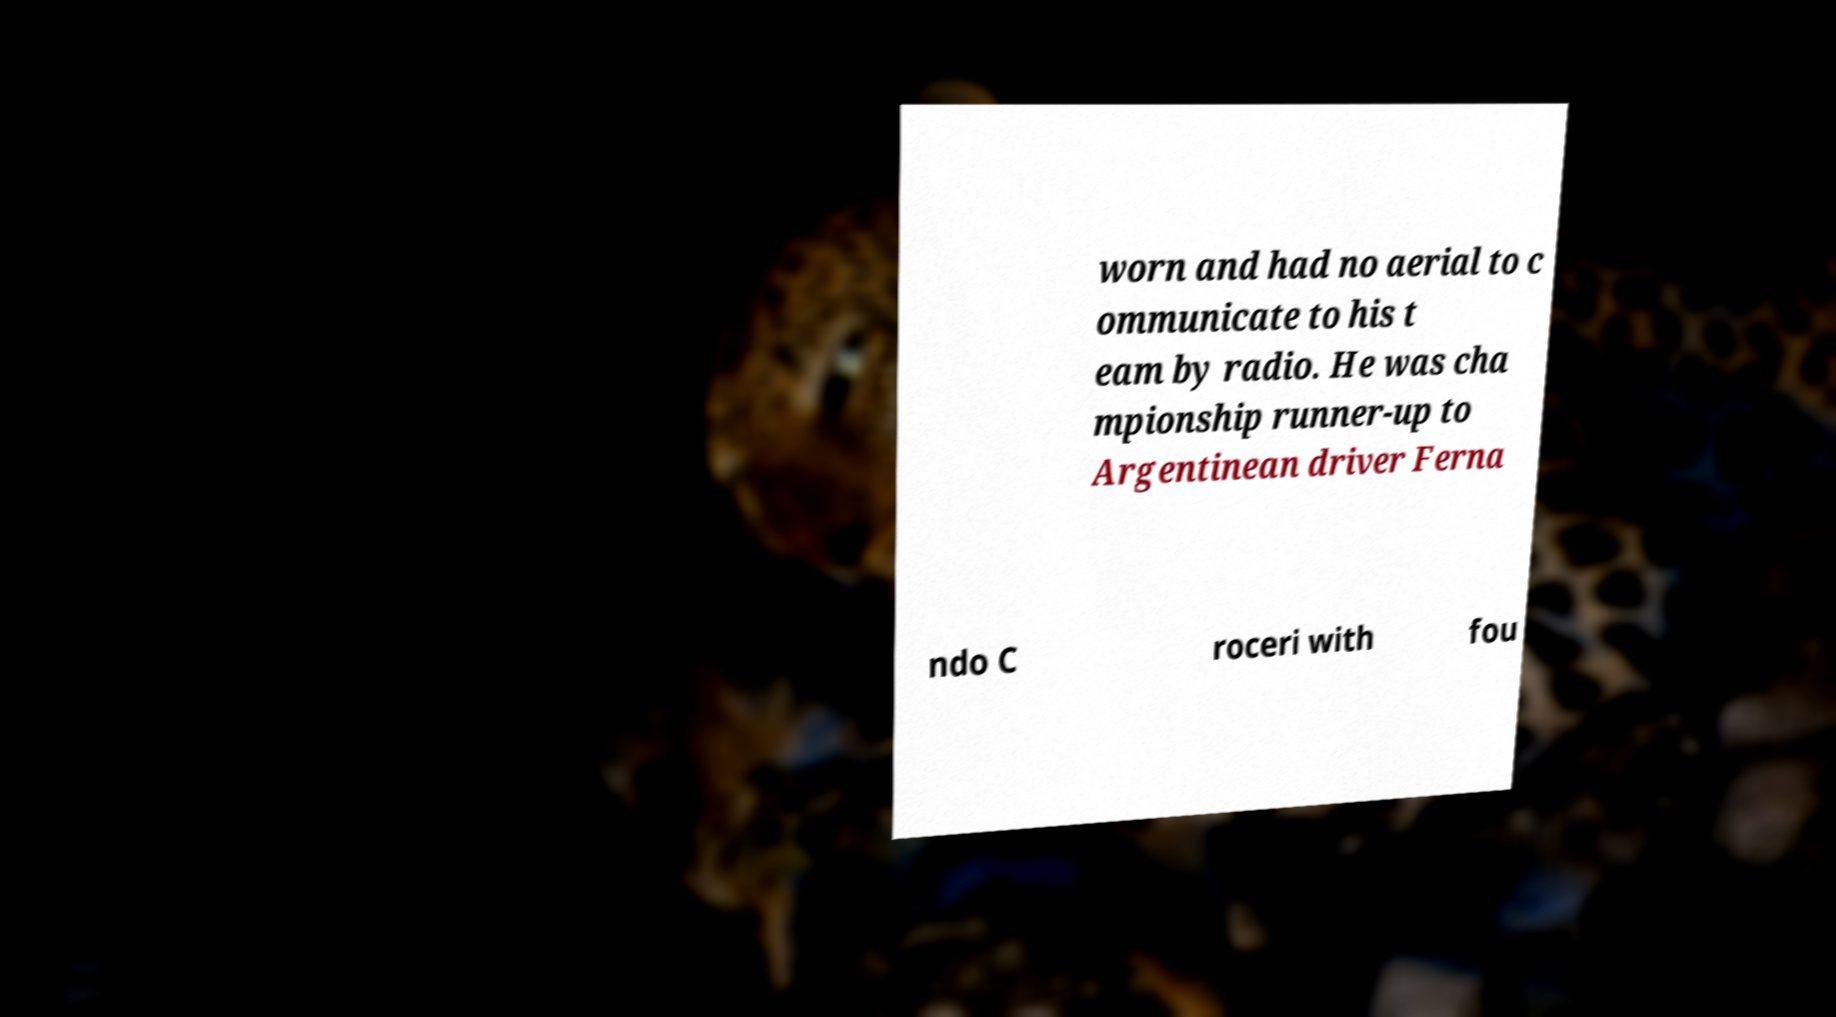Can you read and provide the text displayed in the image?This photo seems to have some interesting text. Can you extract and type it out for me? worn and had no aerial to c ommunicate to his t eam by radio. He was cha mpionship runner-up to Argentinean driver Ferna ndo C roceri with fou 